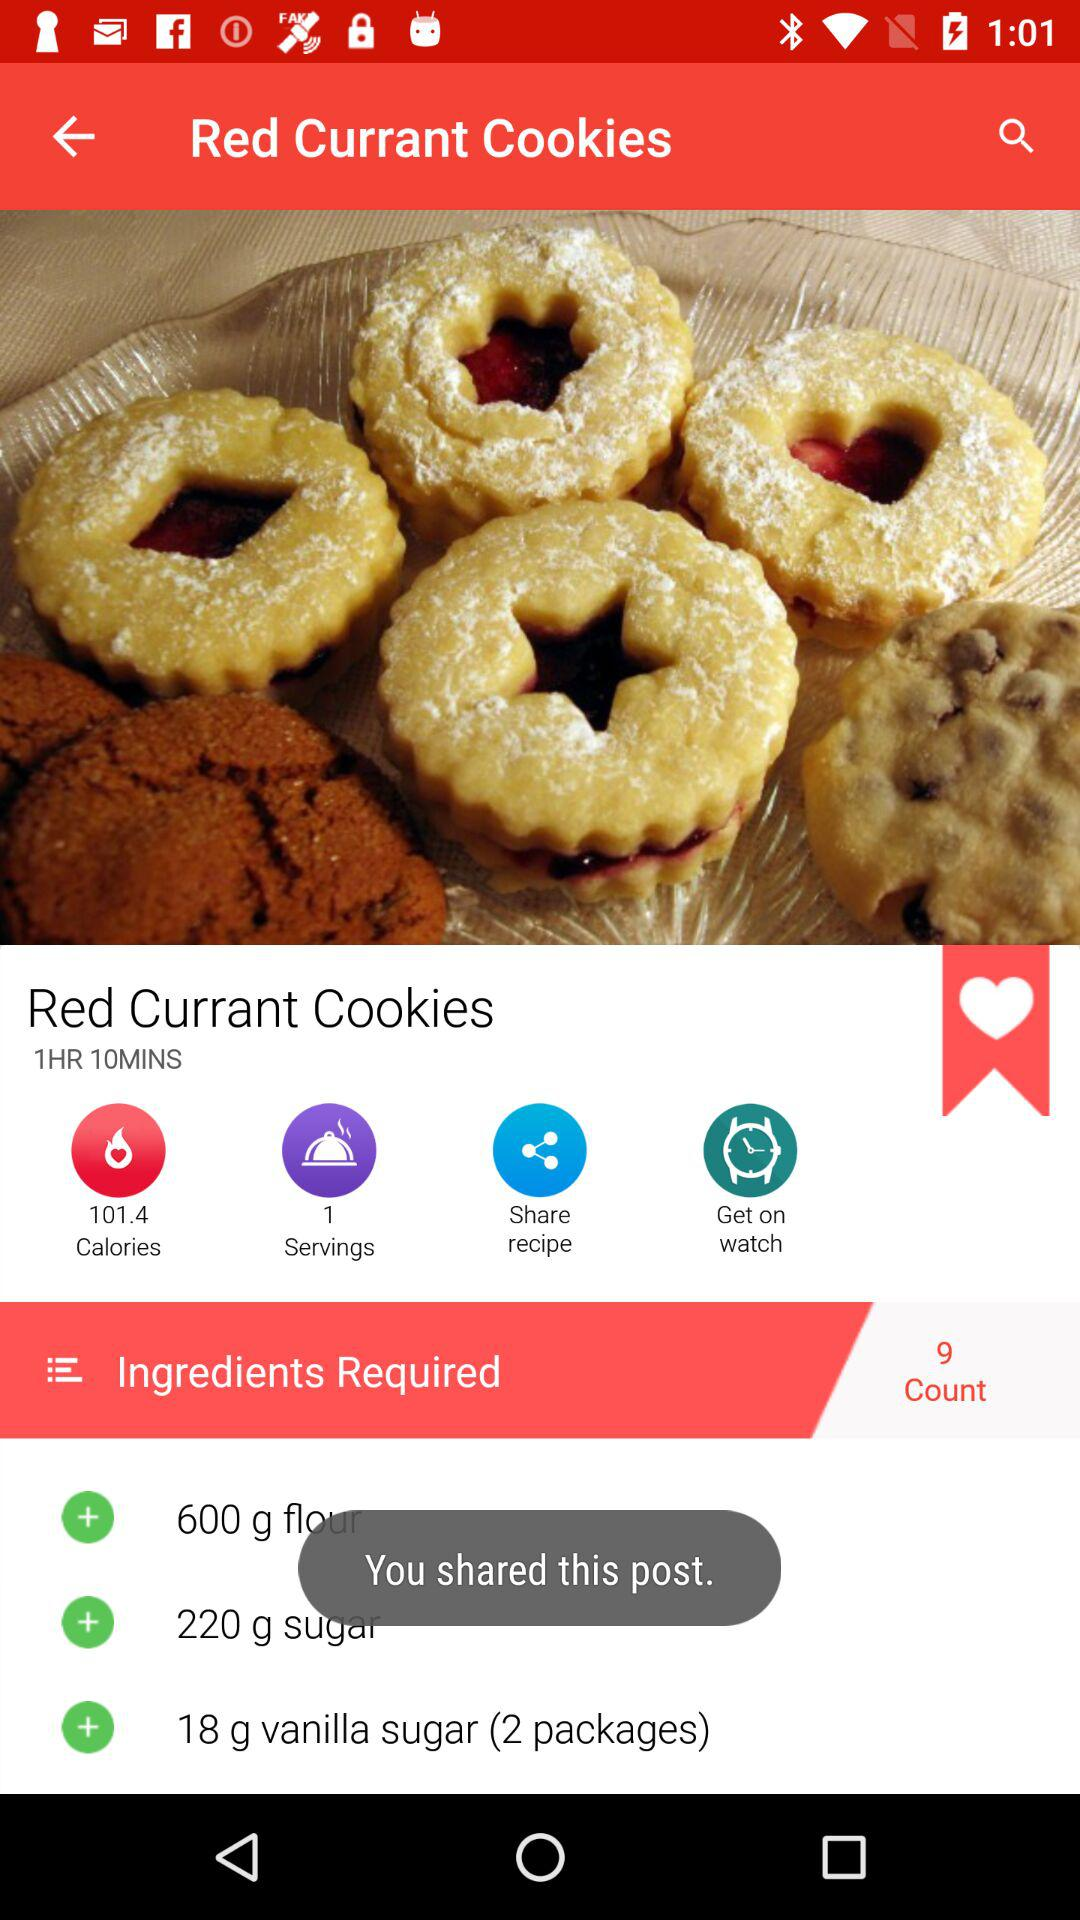To how many people can "Red Currant Cookies" be served? The "Red Currant Cookies" can be served to 1 person. 